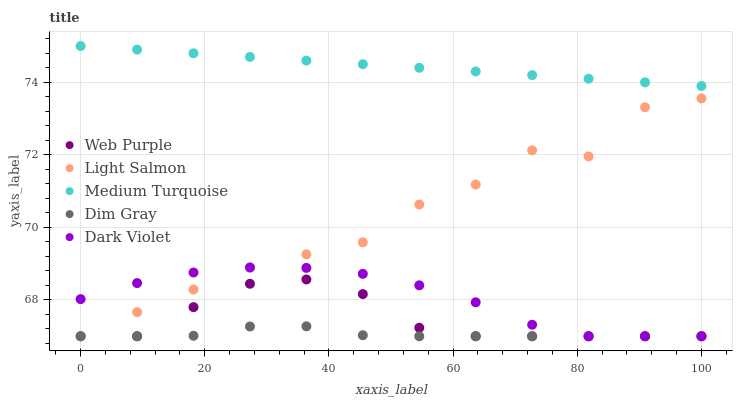Does Dim Gray have the minimum area under the curve?
Answer yes or no. Yes. Does Medium Turquoise have the maximum area under the curve?
Answer yes or no. Yes. Does Dark Violet have the minimum area under the curve?
Answer yes or no. No. Does Dark Violet have the maximum area under the curve?
Answer yes or no. No. Is Medium Turquoise the smoothest?
Answer yes or no. Yes. Is Light Salmon the roughest?
Answer yes or no. Yes. Is Dim Gray the smoothest?
Answer yes or no. No. Is Dim Gray the roughest?
Answer yes or no. No. Does Web Purple have the lowest value?
Answer yes or no. Yes. Does Medium Turquoise have the lowest value?
Answer yes or no. No. Does Medium Turquoise have the highest value?
Answer yes or no. Yes. Does Dark Violet have the highest value?
Answer yes or no. No. Is Web Purple less than Medium Turquoise?
Answer yes or no. Yes. Is Medium Turquoise greater than Dim Gray?
Answer yes or no. Yes. Does Light Salmon intersect Web Purple?
Answer yes or no. Yes. Is Light Salmon less than Web Purple?
Answer yes or no. No. Is Light Salmon greater than Web Purple?
Answer yes or no. No. Does Web Purple intersect Medium Turquoise?
Answer yes or no. No. 